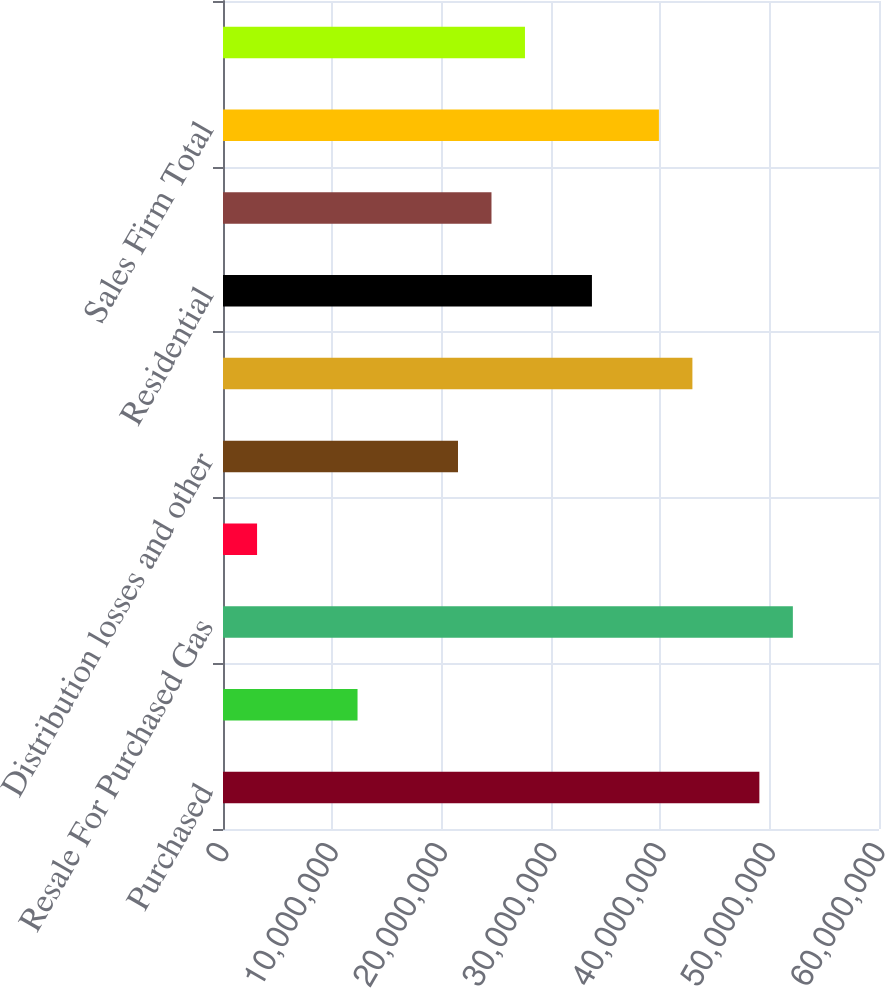Convert chart. <chart><loc_0><loc_0><loc_500><loc_500><bar_chart><fcel>Purchased<fcel>Storage - net change<fcel>Resale For Purchased Gas<fcel>Less Gas used by the company<fcel>Distribution losses and other<fcel>Total Gas Purchased For O&R<fcel>Residential<fcel>General<fcel>Sales Firm Total<fcel>Interruptible Sales<nl><fcel>4.90586e+07<fcel>1.23049e+07<fcel>5.21215e+07<fcel>3.1165e+06<fcel>2.14934e+07<fcel>4.2933e+07<fcel>3.37446e+07<fcel>2.45562e+07<fcel>3.98702e+07<fcel>2.7619e+07<nl></chart> 